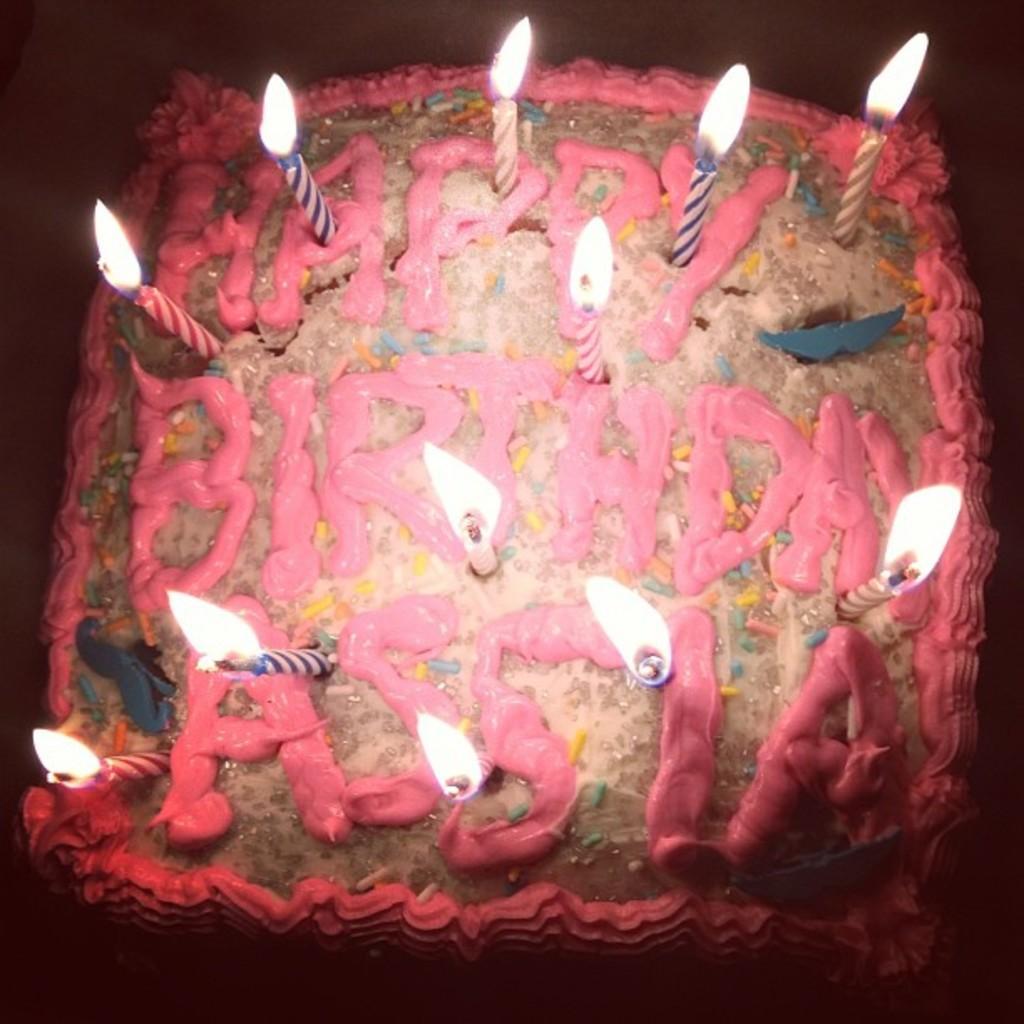How would you summarize this image in a sentence or two? In this image we can see candles with flame on the cake. 